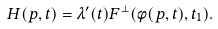Convert formula to latex. <formula><loc_0><loc_0><loc_500><loc_500>H ( p , t ) = \lambda ^ { \prime } ( t ) F ^ { \perp } ( \phi ( p , t ) , t _ { 1 } ) .</formula> 